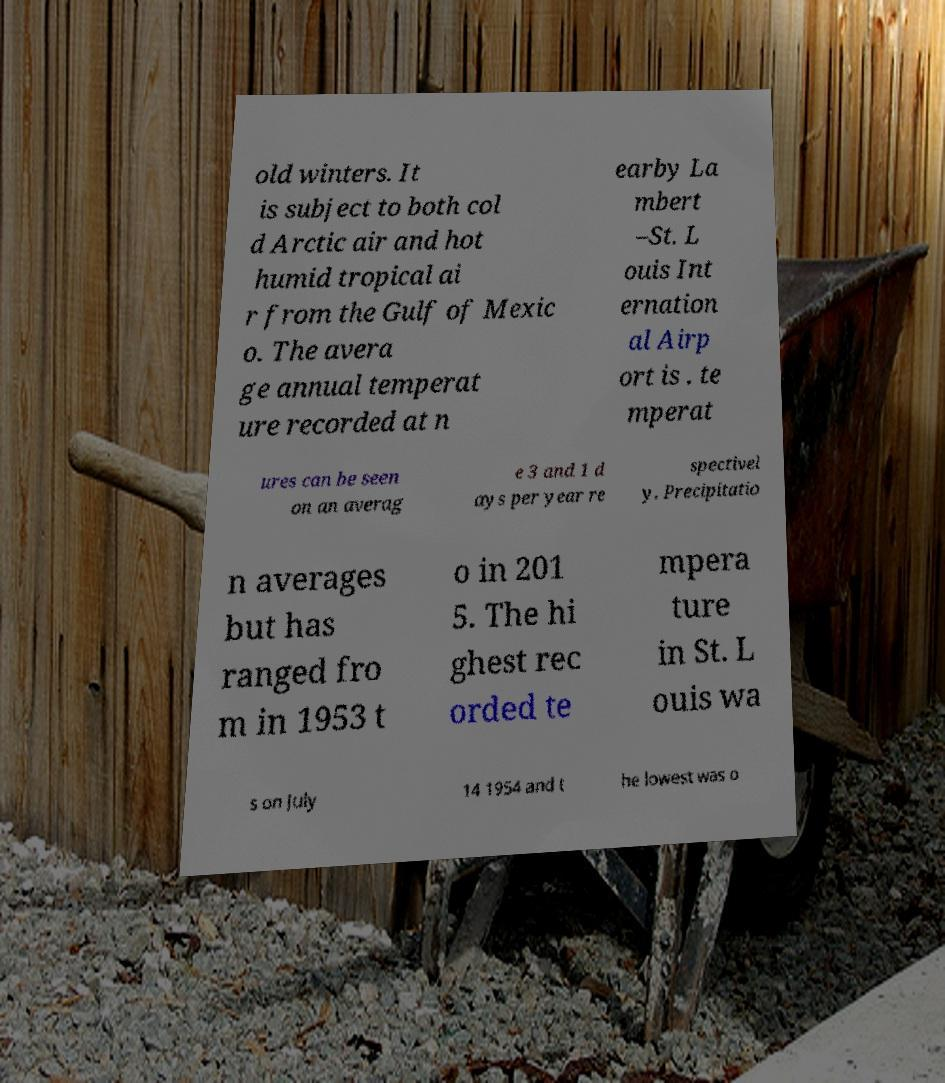Could you extract and type out the text from this image? old winters. It is subject to both col d Arctic air and hot humid tropical ai r from the Gulf of Mexic o. The avera ge annual temperat ure recorded at n earby La mbert –St. L ouis Int ernation al Airp ort is . te mperat ures can be seen on an averag e 3 and 1 d ays per year re spectivel y. Precipitatio n averages but has ranged fro m in 1953 t o in 201 5. The hi ghest rec orded te mpera ture in St. L ouis wa s on July 14 1954 and t he lowest was o 